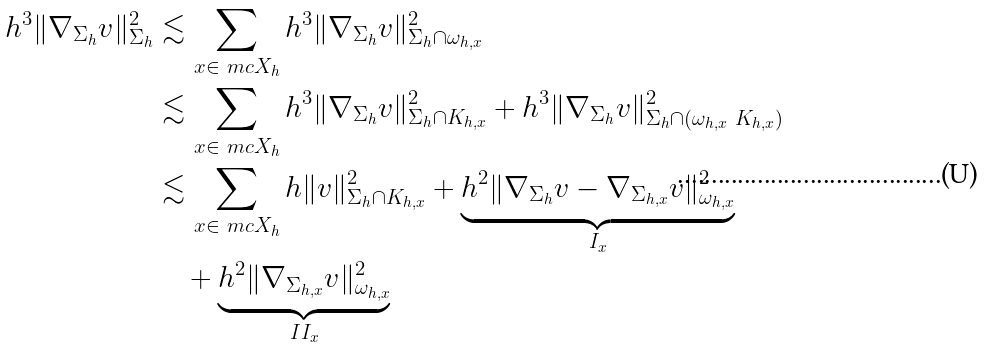Convert formula to latex. <formula><loc_0><loc_0><loc_500><loc_500>h ^ { 3 } \| \nabla _ { \Sigma _ { h } } v \| ^ { 2 } _ { \Sigma _ { h } } & \lesssim \sum _ { x \in \ m c X _ { h } } h ^ { 3 } \| \nabla _ { \Sigma _ { h } } v \| ^ { 2 } _ { \Sigma _ { h } \cap \omega _ { h , x } } \\ & \lesssim \sum _ { x \in \ m c X _ { h } } h ^ { 3 } \| \nabla _ { \Sigma _ { h } } v \| ^ { 2 } _ { \Sigma _ { h } \cap K _ { h , x } } + h ^ { 3 } \| \nabla _ { \Sigma _ { h } } v \| ^ { 2 } _ { \Sigma _ { h } \cap ( \omega _ { h , x } \ K _ { h , x } ) } \\ & \lesssim \sum _ { x \in \ m c X _ { h } } h \| v \| ^ { 2 } _ { \Sigma _ { h } \cap K _ { h , x } } + \underbrace { h ^ { 2 } \| \nabla _ { \Sigma _ { h } } v - \nabla _ { \Sigma _ { h , x } } v \| ^ { 2 } _ { \omega _ { h , x } } } _ { I _ { x } } \\ & \quad + \underbrace { h ^ { 2 } \| \nabla _ { \Sigma _ { h , x } } v \| ^ { 2 } _ { \omega _ { h , x } } } _ { I I _ { x } }</formula> 